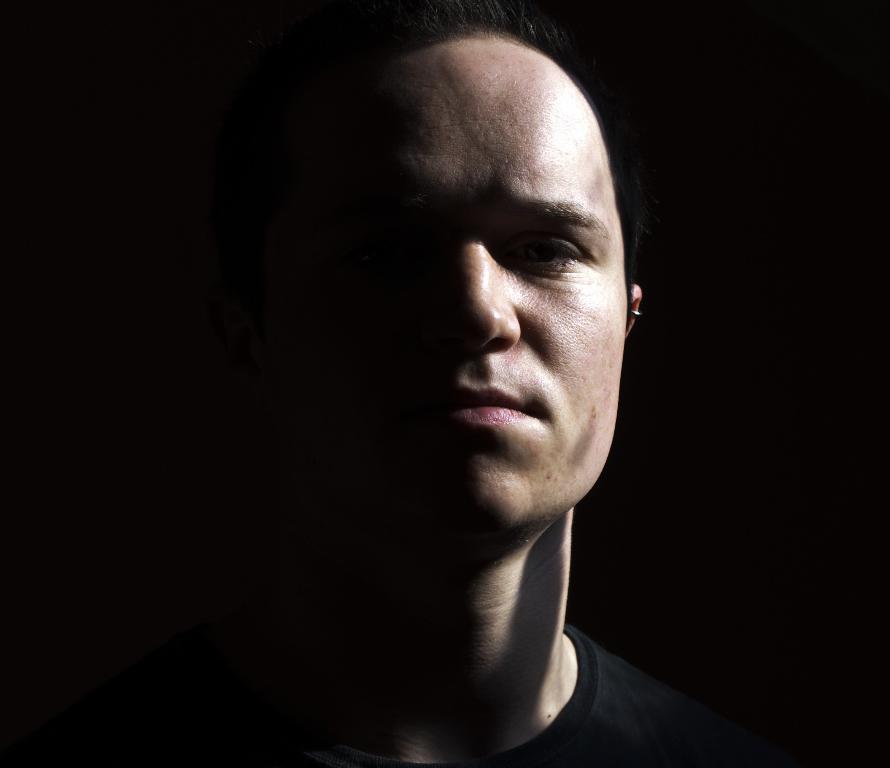Describe this image in one or two sentences. In this image there is a person. 